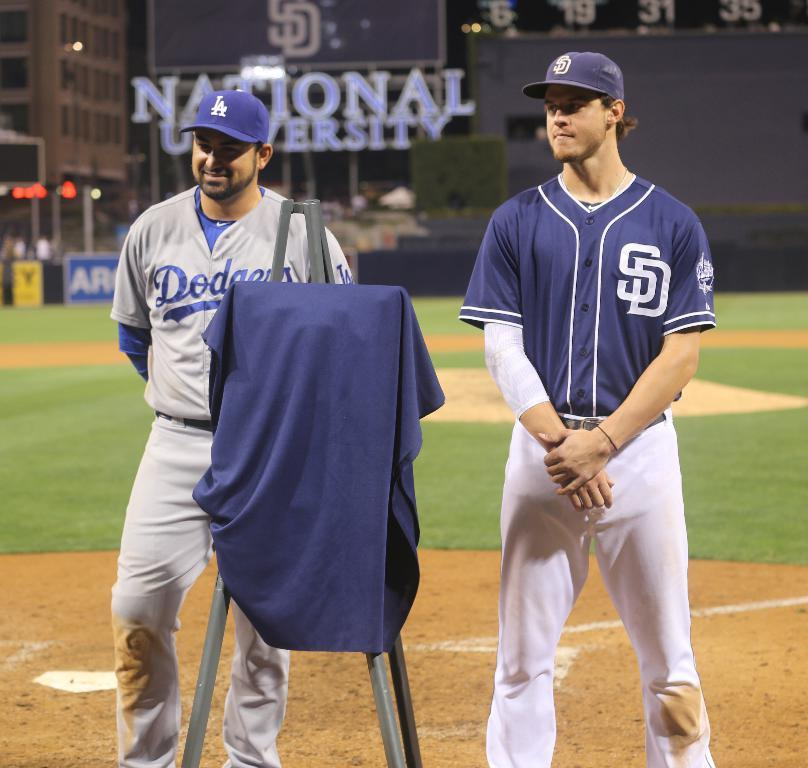<image>
Provide a brief description of the given image. Baseball players standing in front of a National University sign in blue. 